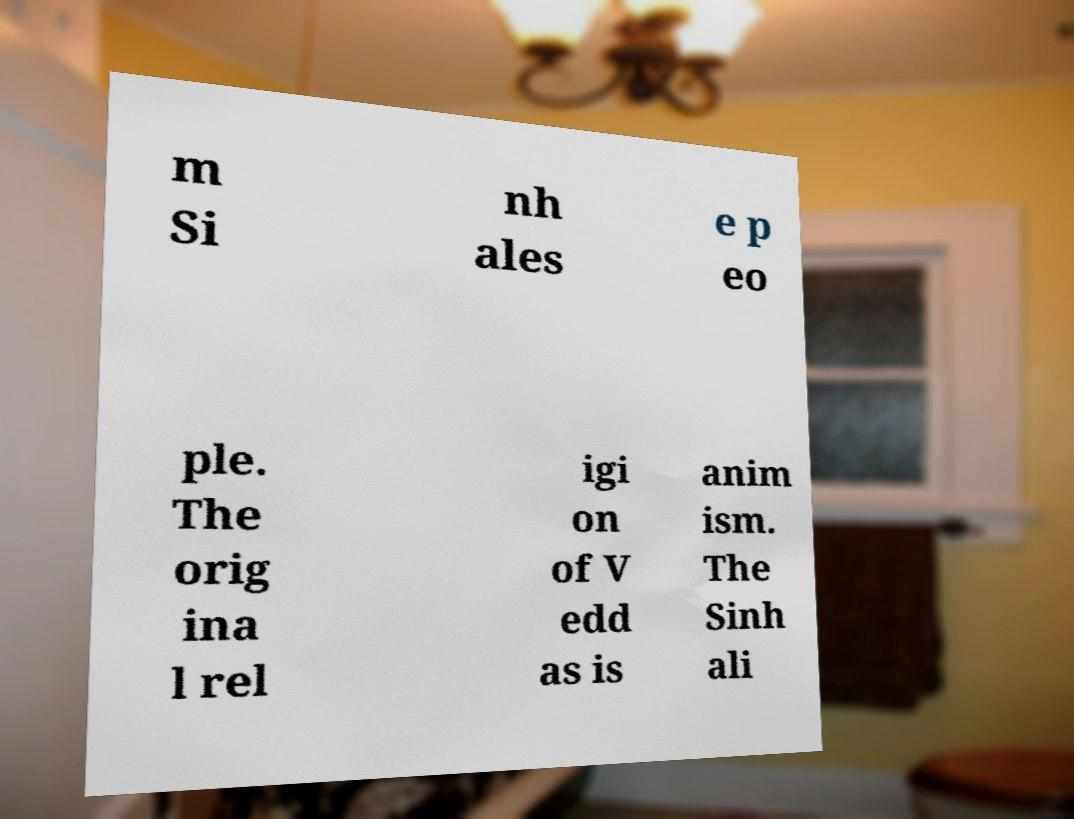What messages or text are displayed in this image? I need them in a readable, typed format. m Si nh ales e p eo ple. The orig ina l rel igi on of V edd as is anim ism. The Sinh ali 